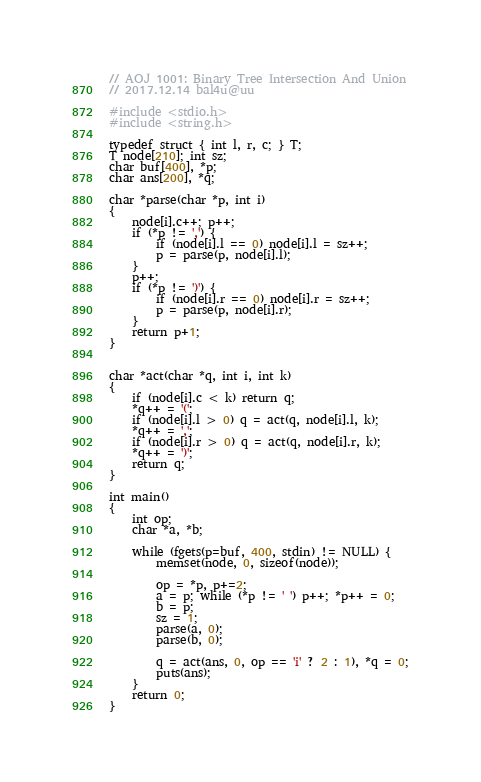Convert code to text. <code><loc_0><loc_0><loc_500><loc_500><_C_>// AOJ 1001: Binary Tree Intersection And Union
// 2017.12.14 bal4u@uu

#include <stdio.h>
#include <string.h>

typedef struct { int l, r, c; } T;
T node[210]; int sz;
char buf[400], *p;
char ans[200], *q;

char *parse(char *p, int i)
{
	node[i].c++; p++;
	if (*p != ',') {
	    if (node[i].l == 0) node[i].l = sz++;
		p = parse(p, node[i].l);
	}
	p++;
	if (*p != ')') {
		if (node[i].r == 0) node[i].r = sz++;
	    p = parse(p, node[i].r);
	}
	return p+1;
}


char *act(char *q, int i, int k)
{
	if (node[i].c < k) return q;
	*q++ = '(';
	if (node[i].l > 0) q = act(q, node[i].l, k);
	*q++ = ',';
	if (node[i].r > 0) q = act(q, node[i].r, k);
	*q++ = ')';
	return q;
}

int main()
{
	int op;
	char *a, *b;

	while (fgets(p=buf, 400, stdin) != NULL) {
		memset(node, 0, sizeof(node));

		op = *p, p+=2;
		a = p; while (*p != ' ') p++; *p++ = 0;
		b = p;
		sz = 1;
		parse(a, 0);
		parse(b, 0);

		q = act(ans, 0, op == 'i' ? 2 : 1), *q = 0;
		puts(ans);
	}
	return 0;
}</code> 